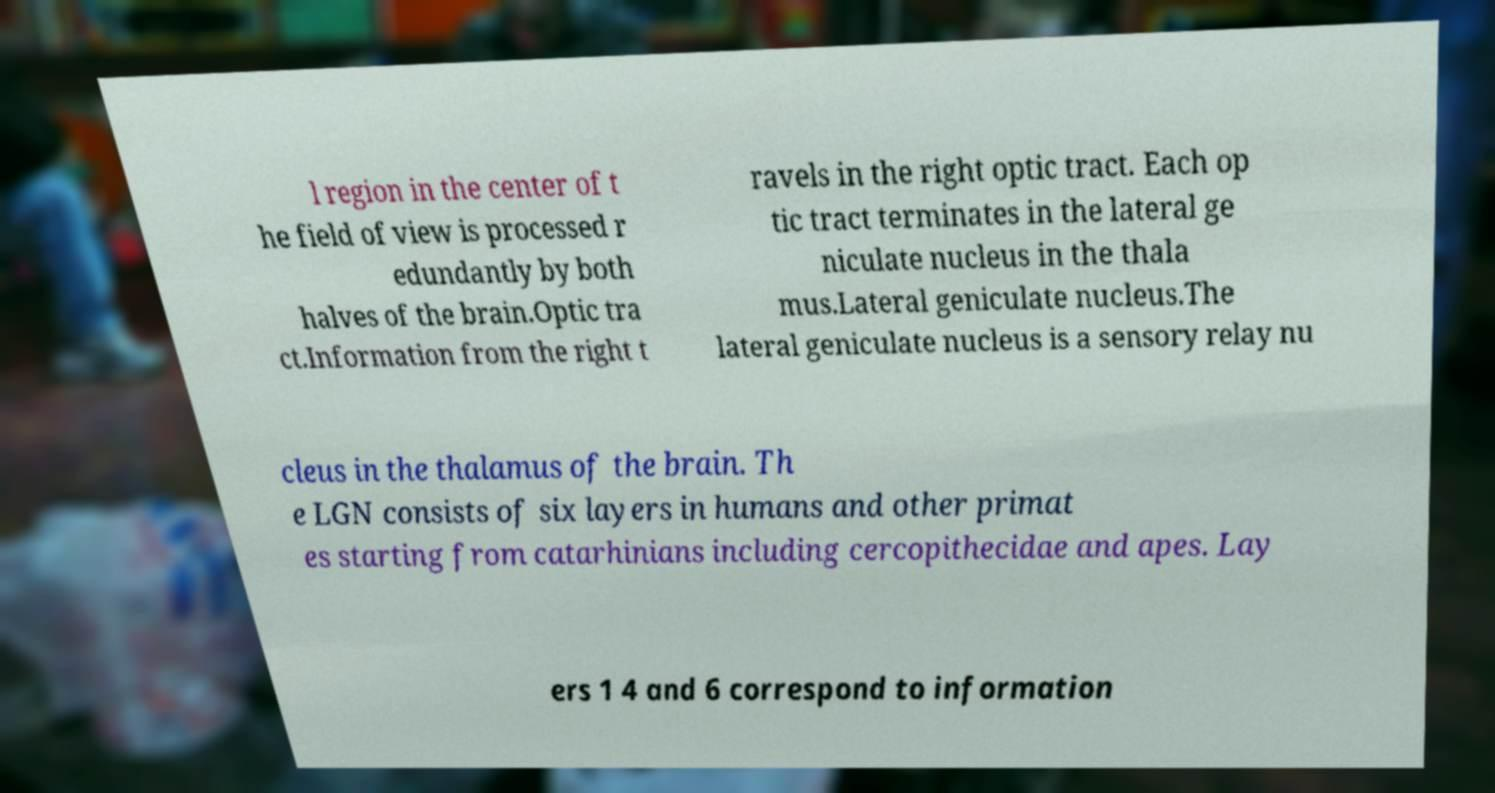Could you assist in decoding the text presented in this image and type it out clearly? l region in the center of t he field of view is processed r edundantly by both halves of the brain.Optic tra ct.Information from the right t ravels in the right optic tract. Each op tic tract terminates in the lateral ge niculate nucleus in the thala mus.Lateral geniculate nucleus.The lateral geniculate nucleus is a sensory relay nu cleus in the thalamus of the brain. Th e LGN consists of six layers in humans and other primat es starting from catarhinians including cercopithecidae and apes. Lay ers 1 4 and 6 correspond to information 